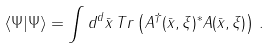<formula> <loc_0><loc_0><loc_500><loc_500>\langle \Psi | \Psi \rangle = \int d ^ { d } \bar { x } \, T r \left ( A ^ { \dagger } ( \bar { x } , \xi ) ^ { * } A ( \bar { x } , \xi ) \right ) \, .</formula> 